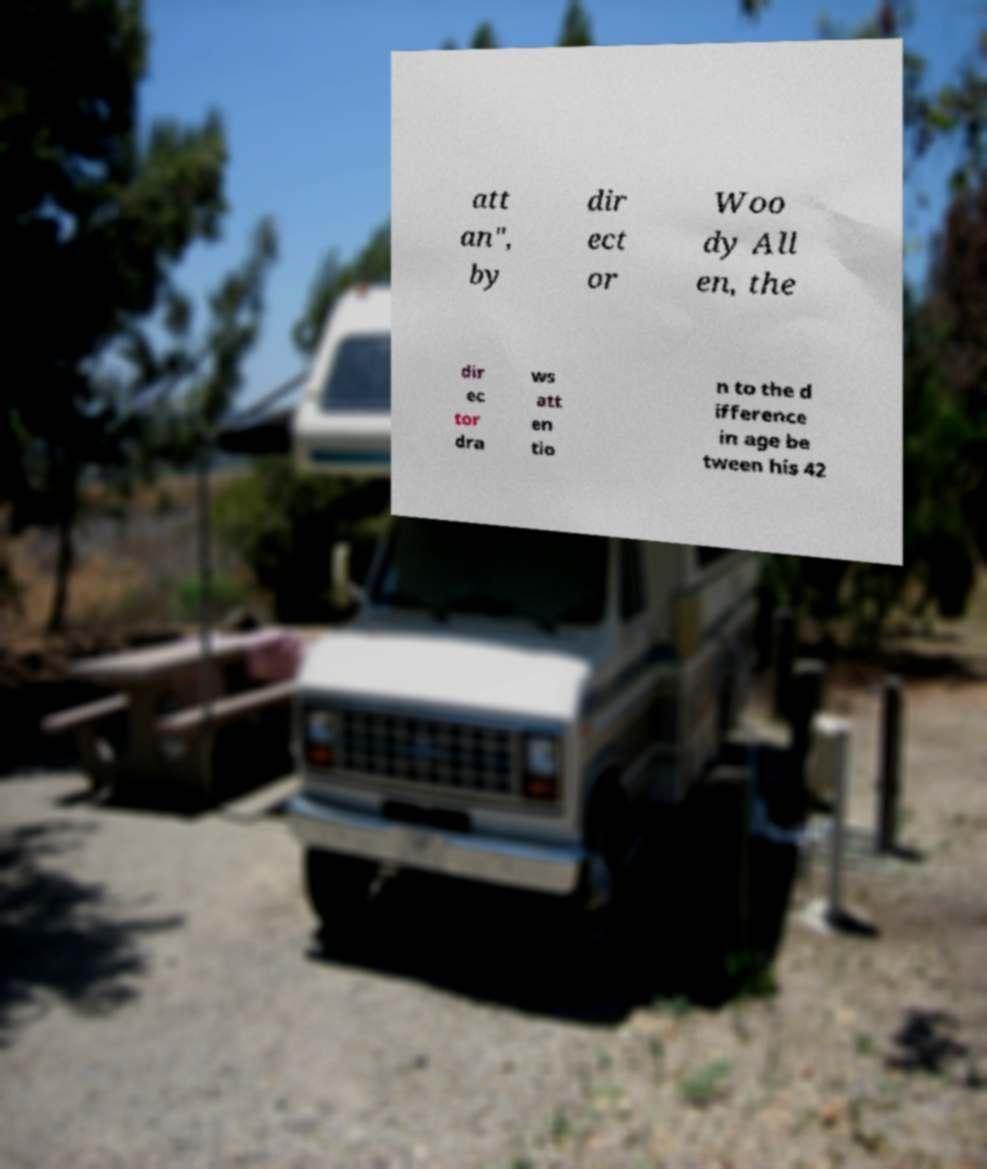Please read and relay the text visible in this image. What does it say? att an", by dir ect or Woo dy All en, the dir ec tor dra ws att en tio n to the d ifference in age be tween his 42 